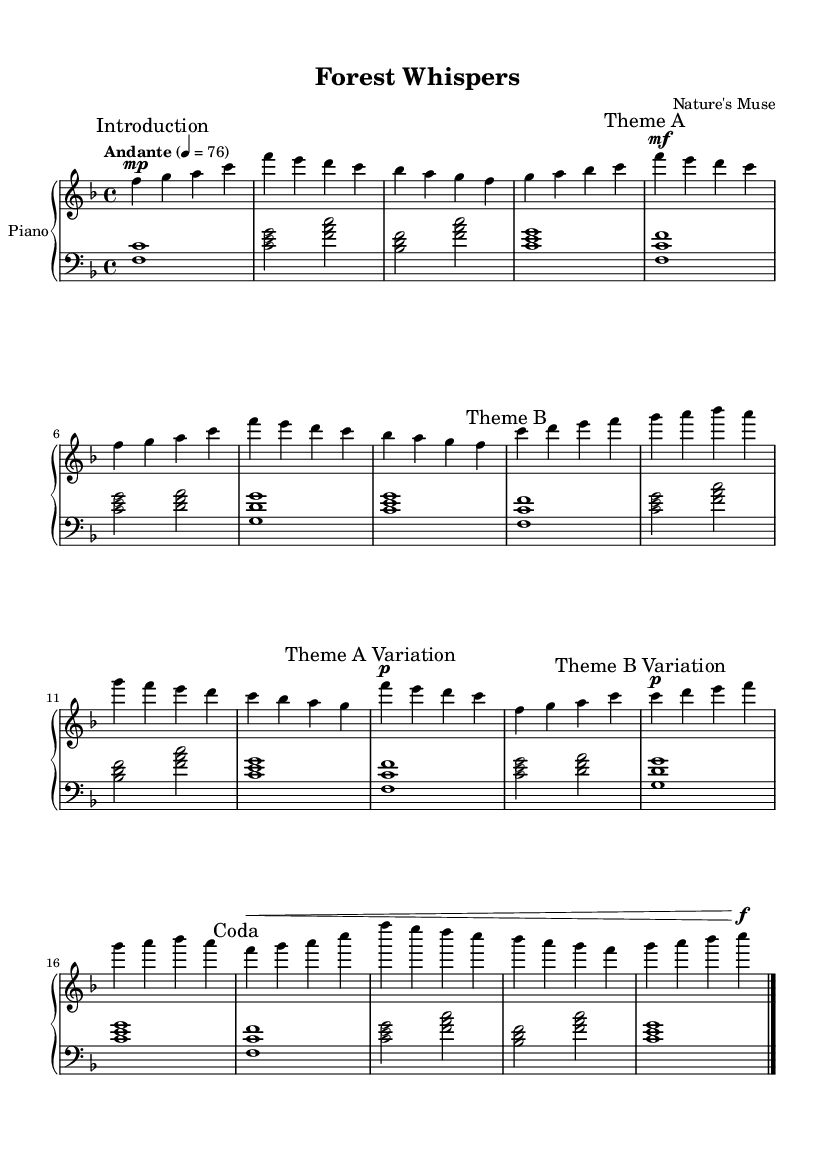What is the key signature of this music? The key signature shows one flat (B♭), indicating that it is in F major.
Answer: F major What is the time signature of this piece? The time signature is 4/4, which indicates four beats per measure, with a quarter note receiving one beat.
Answer: 4/4 What is the tempo marking for this piece? The tempo marking is "Andante," which typically indicates a moderately slow tempo around 76 beats per minute.
Answer: Andante How many themes are presented in this piece? The score contains two main themes: Theme A and Theme B, along with variations of each.
Answer: Two What does the dynamic marking "mf" indicate in the music? "mf" stands for mezzo-forte, meaning moderately loud; it instructs the player to play that section with medium volume.
Answer: Moderately loud Which section indicates a quieter dynamic with "p"? The sections marked with "p" (piano) indicate they should be played softly, showing a contrast to other sections.
Answer: Theme A Variation and Theme B Variation What does the term "coda" refer to in this context? "Coda" refers to the concluding section of the piece, providing a sense of closure in the music before resolving.
Answer: Coda 